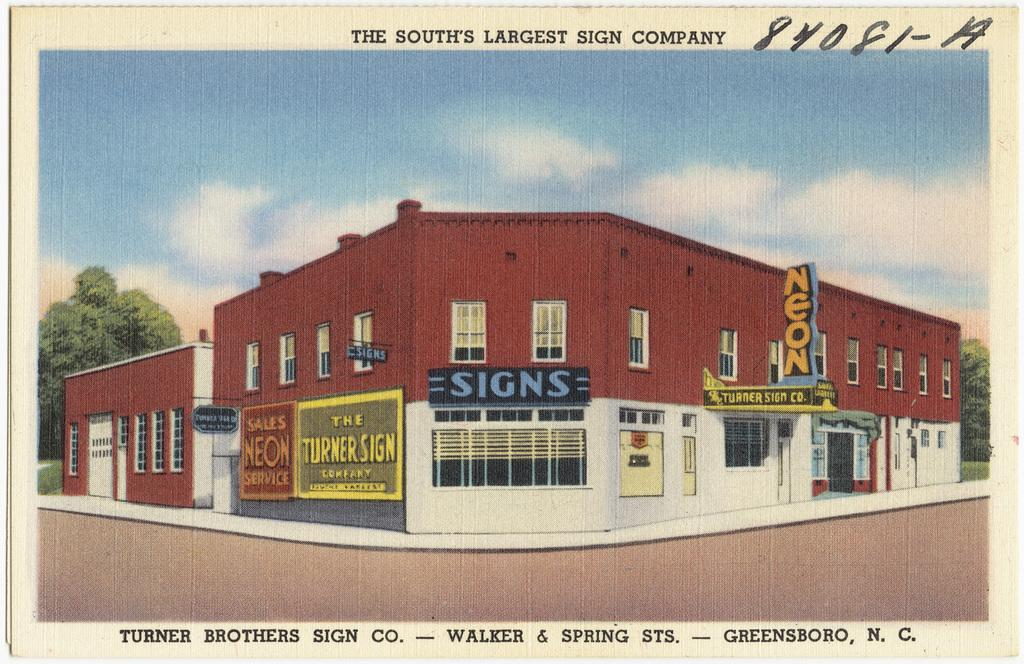What type of structure is present in the image? There is a building in the image. What color is the building? The building is colored red. What can be seen on the left side of the image? There is a tree on the left side of the image. What is visible in the background of the image? The sky is visible in the background of the image. Can you compare the size of the ghost in the image to the building? There is no ghost present in the image, so it cannot be compared to the building. 